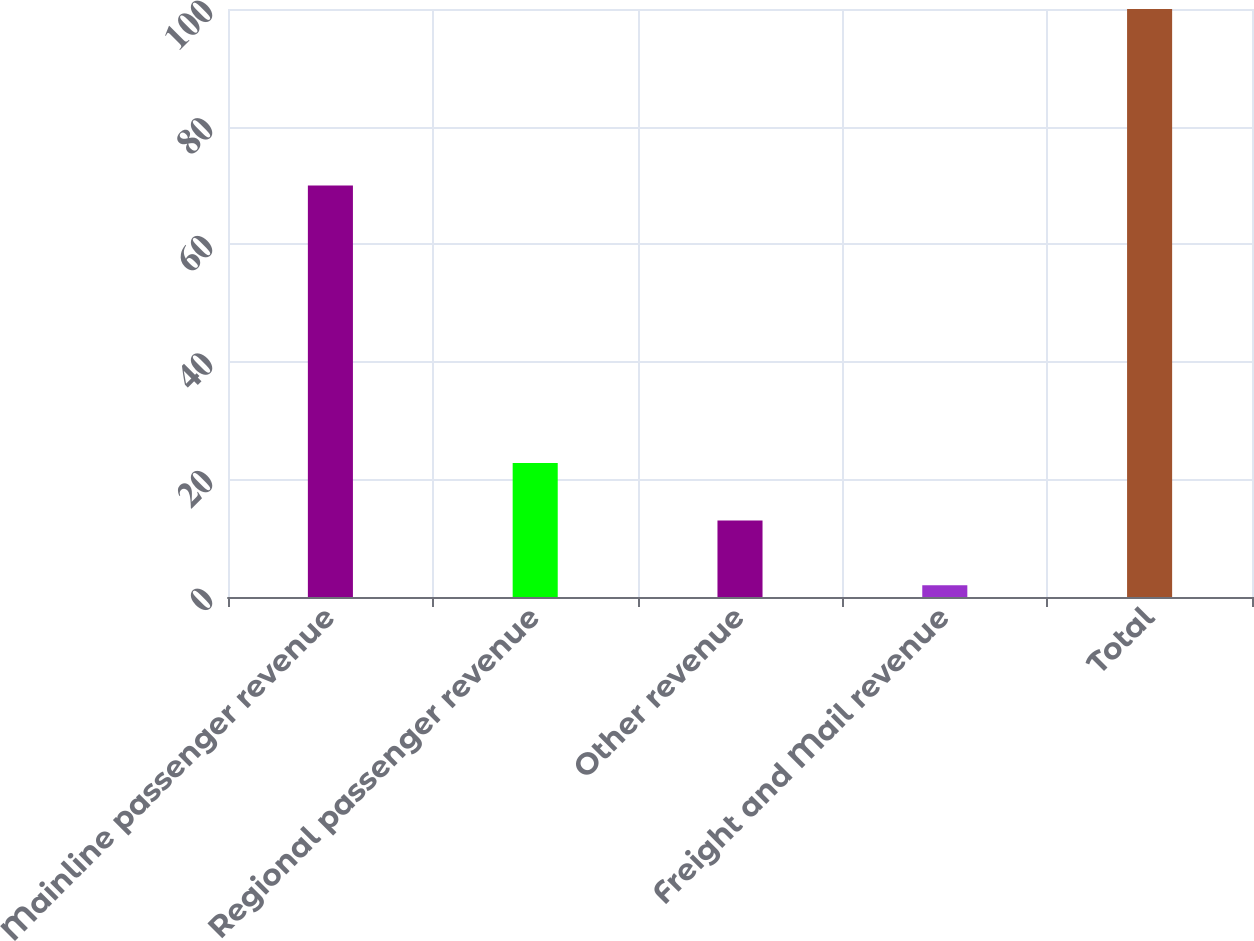Convert chart. <chart><loc_0><loc_0><loc_500><loc_500><bar_chart><fcel>Mainline passenger revenue<fcel>Regional passenger revenue<fcel>Other revenue<fcel>Freight and Mail revenue<fcel>Total<nl><fcel>70<fcel>22.8<fcel>13<fcel>2<fcel>100<nl></chart> 